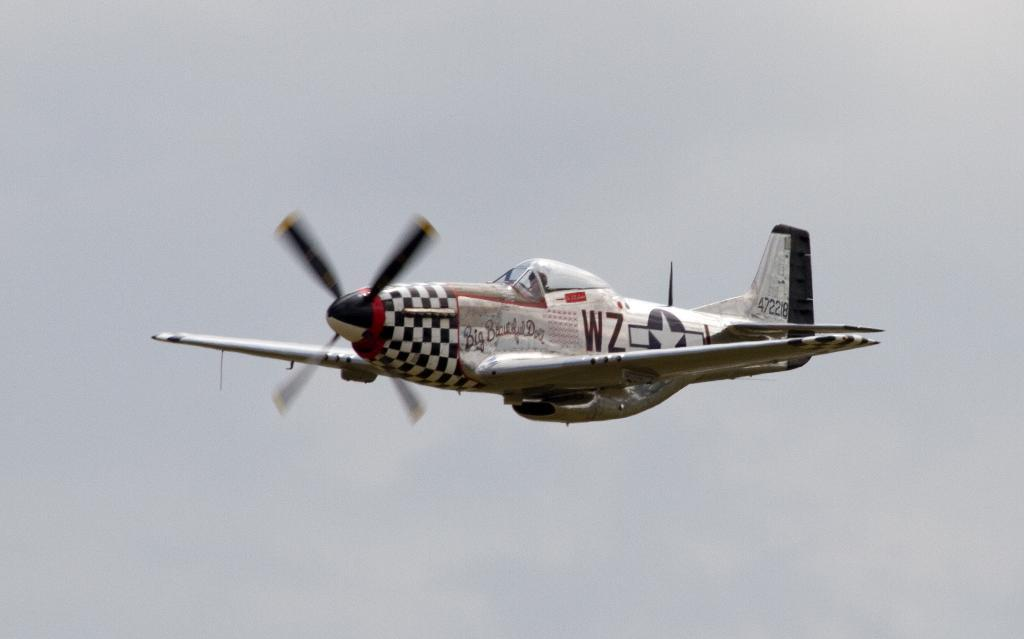What is the main subject of the image? The main subject of the image is an airplane. Where is the airplane located in the image? The airplane is in the center of the image. What can be seen in the background of the image? The sky and clouds are visible in the background of the image. Can you see a flock of kisses flying around the airplane in the image? There are no kisses or flocks of kisses present in the image. 